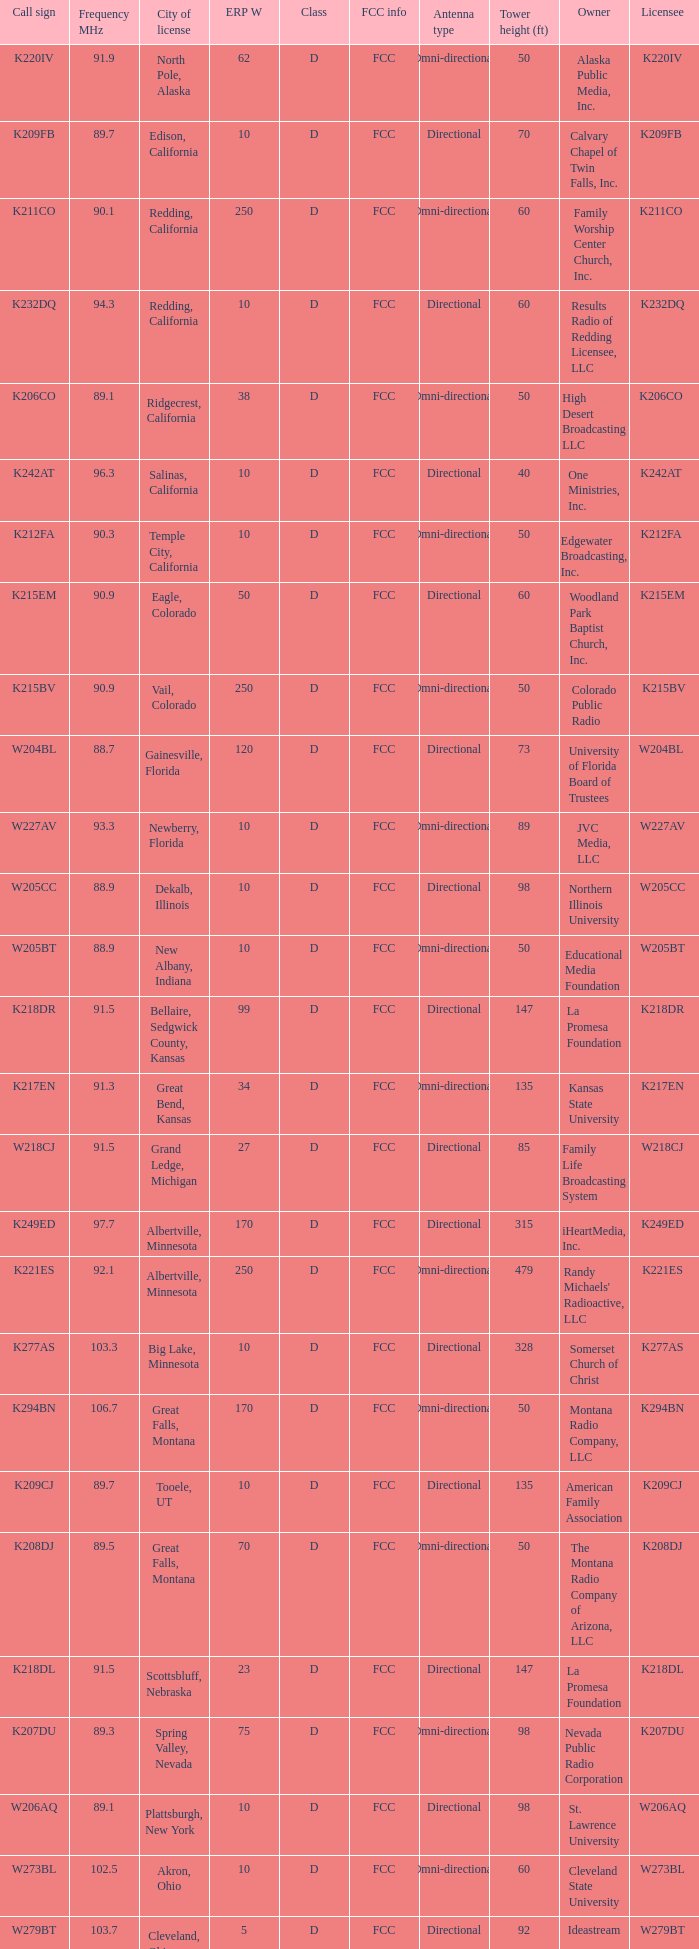What is the class of the translator with 10 ERP W and a call sign of w273bl? D. 